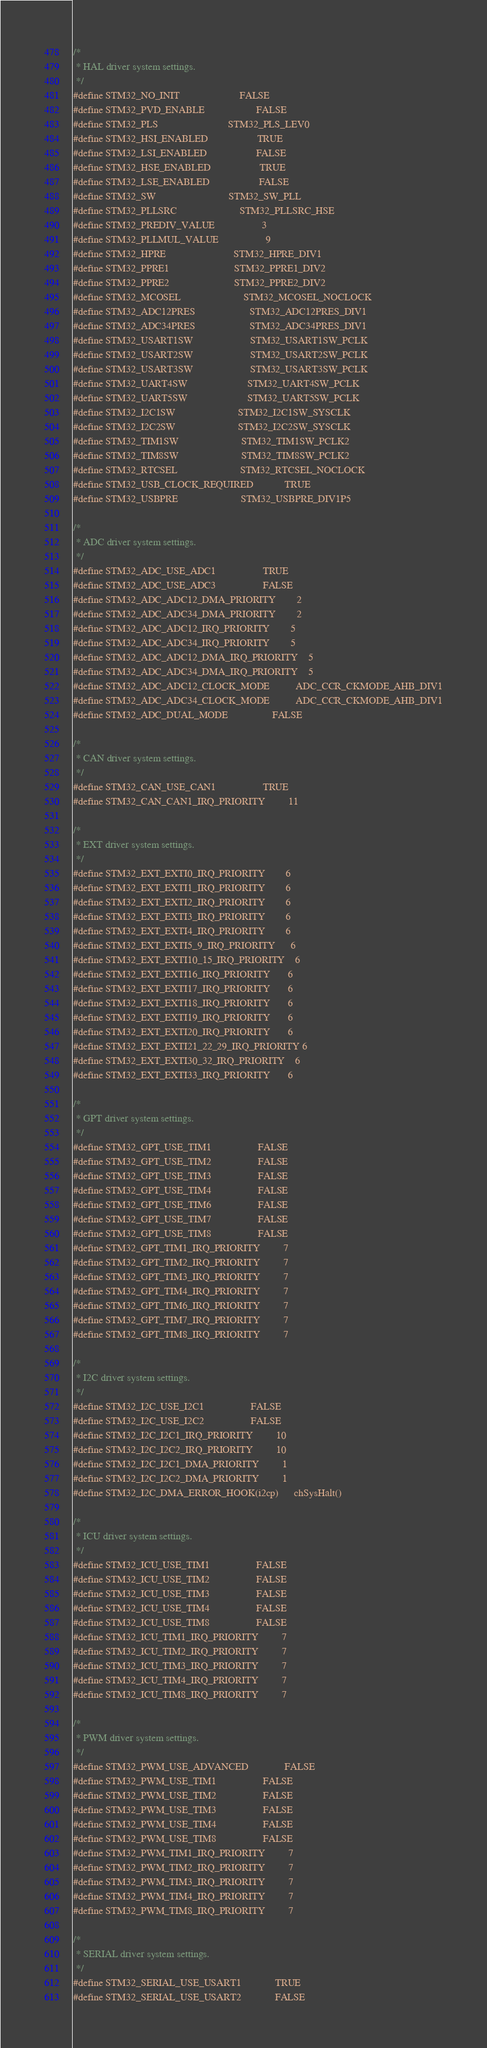<code> <loc_0><loc_0><loc_500><loc_500><_C_>
/*
 * HAL driver system settings.
 */
#define STM32_NO_INIT                       FALSE
#define STM32_PVD_ENABLE                    FALSE
#define STM32_PLS                           STM32_PLS_LEV0
#define STM32_HSI_ENABLED                   TRUE
#define STM32_LSI_ENABLED                   FALSE
#define STM32_HSE_ENABLED                   TRUE
#define STM32_LSE_ENABLED                   FALSE
#define STM32_SW                            STM32_SW_PLL
#define STM32_PLLSRC                        STM32_PLLSRC_HSE
#define STM32_PREDIV_VALUE                  3
#define STM32_PLLMUL_VALUE                  9
#define STM32_HPRE                          STM32_HPRE_DIV1
#define STM32_PPRE1                         STM32_PPRE1_DIV2
#define STM32_PPRE2                         STM32_PPRE2_DIV2
#define STM32_MCOSEL                        STM32_MCOSEL_NOCLOCK
#define STM32_ADC12PRES                     STM32_ADC12PRES_DIV1
#define STM32_ADC34PRES                     STM32_ADC34PRES_DIV1
#define STM32_USART1SW                      STM32_USART1SW_PCLK
#define STM32_USART2SW                      STM32_USART2SW_PCLK
#define STM32_USART3SW                      STM32_USART3SW_PCLK
#define STM32_UART4SW                       STM32_UART4SW_PCLK
#define STM32_UART5SW                       STM32_UART5SW_PCLK
#define STM32_I2C1SW                        STM32_I2C1SW_SYSCLK
#define STM32_I2C2SW                        STM32_I2C2SW_SYSCLK
#define STM32_TIM1SW                        STM32_TIM1SW_PCLK2
#define STM32_TIM8SW                        STM32_TIM8SW_PCLK2
#define STM32_RTCSEL                        STM32_RTCSEL_NOCLOCK
#define STM32_USB_CLOCK_REQUIRED            TRUE
#define STM32_USBPRE                        STM32_USBPRE_DIV1P5

/*
 * ADC driver system settings.
 */
#define STM32_ADC_USE_ADC1                  TRUE
#define STM32_ADC_USE_ADC3                  FALSE
#define STM32_ADC_ADC12_DMA_PRIORITY        2
#define STM32_ADC_ADC34_DMA_PRIORITY        2
#define STM32_ADC_ADC12_IRQ_PRIORITY        5
#define STM32_ADC_ADC34_IRQ_PRIORITY        5
#define STM32_ADC_ADC12_DMA_IRQ_PRIORITY    5
#define STM32_ADC_ADC34_DMA_IRQ_PRIORITY    5
#define STM32_ADC_ADC12_CLOCK_MODE          ADC_CCR_CKMODE_AHB_DIV1
#define STM32_ADC_ADC34_CLOCK_MODE          ADC_CCR_CKMODE_AHB_DIV1
#define STM32_ADC_DUAL_MODE                 FALSE

/*
 * CAN driver system settings.
 */
#define STM32_CAN_USE_CAN1                  TRUE
#define STM32_CAN_CAN1_IRQ_PRIORITY         11

/*
 * EXT driver system settings.
 */
#define STM32_EXT_EXTI0_IRQ_PRIORITY        6
#define STM32_EXT_EXTI1_IRQ_PRIORITY        6
#define STM32_EXT_EXTI2_IRQ_PRIORITY        6
#define STM32_EXT_EXTI3_IRQ_PRIORITY        6
#define STM32_EXT_EXTI4_IRQ_PRIORITY        6
#define STM32_EXT_EXTI5_9_IRQ_PRIORITY      6
#define STM32_EXT_EXTI10_15_IRQ_PRIORITY    6
#define STM32_EXT_EXTI16_IRQ_PRIORITY       6
#define STM32_EXT_EXTI17_IRQ_PRIORITY       6
#define STM32_EXT_EXTI18_IRQ_PRIORITY       6
#define STM32_EXT_EXTI19_IRQ_PRIORITY       6
#define STM32_EXT_EXTI20_IRQ_PRIORITY       6
#define STM32_EXT_EXTI21_22_29_IRQ_PRIORITY 6
#define STM32_EXT_EXTI30_32_IRQ_PRIORITY    6
#define STM32_EXT_EXTI33_IRQ_PRIORITY       6

/*
 * GPT driver system settings.
 */
#define STM32_GPT_USE_TIM1                  FALSE
#define STM32_GPT_USE_TIM2                  FALSE
#define STM32_GPT_USE_TIM3                  FALSE
#define STM32_GPT_USE_TIM4                  FALSE
#define STM32_GPT_USE_TIM6                  FALSE
#define STM32_GPT_USE_TIM7                  FALSE
#define STM32_GPT_USE_TIM8                  FALSE
#define STM32_GPT_TIM1_IRQ_PRIORITY         7
#define STM32_GPT_TIM2_IRQ_PRIORITY         7
#define STM32_GPT_TIM3_IRQ_PRIORITY         7
#define STM32_GPT_TIM4_IRQ_PRIORITY         7
#define STM32_GPT_TIM6_IRQ_PRIORITY         7
#define STM32_GPT_TIM7_IRQ_PRIORITY         7
#define STM32_GPT_TIM8_IRQ_PRIORITY         7

/*
 * I2C driver system settings.
 */
#define STM32_I2C_USE_I2C1                  FALSE
#define STM32_I2C_USE_I2C2                  FALSE
#define STM32_I2C_I2C1_IRQ_PRIORITY         10
#define STM32_I2C_I2C2_IRQ_PRIORITY         10
#define STM32_I2C_I2C1_DMA_PRIORITY         1
#define STM32_I2C_I2C2_DMA_PRIORITY         1
#define STM32_I2C_DMA_ERROR_HOOK(i2cp)      chSysHalt()

/*
 * ICU driver system settings.
 */
#define STM32_ICU_USE_TIM1                  FALSE
#define STM32_ICU_USE_TIM2                  FALSE
#define STM32_ICU_USE_TIM3                  FALSE
#define STM32_ICU_USE_TIM4                  FALSE
#define STM32_ICU_USE_TIM8                  FALSE
#define STM32_ICU_TIM1_IRQ_PRIORITY         7
#define STM32_ICU_TIM2_IRQ_PRIORITY         7
#define STM32_ICU_TIM3_IRQ_PRIORITY         7
#define STM32_ICU_TIM4_IRQ_PRIORITY         7
#define STM32_ICU_TIM8_IRQ_PRIORITY         7

/*
 * PWM driver system settings.
 */
#define STM32_PWM_USE_ADVANCED              FALSE
#define STM32_PWM_USE_TIM1                  FALSE
#define STM32_PWM_USE_TIM2                  FALSE
#define STM32_PWM_USE_TIM3                  FALSE
#define STM32_PWM_USE_TIM4                  FALSE
#define STM32_PWM_USE_TIM8                  FALSE
#define STM32_PWM_TIM1_IRQ_PRIORITY         7
#define STM32_PWM_TIM2_IRQ_PRIORITY         7
#define STM32_PWM_TIM3_IRQ_PRIORITY         7
#define STM32_PWM_TIM4_IRQ_PRIORITY         7
#define STM32_PWM_TIM8_IRQ_PRIORITY         7

/*
 * SERIAL driver system settings.
 */
#define STM32_SERIAL_USE_USART1             TRUE
#define STM32_SERIAL_USE_USART2             FALSE</code> 